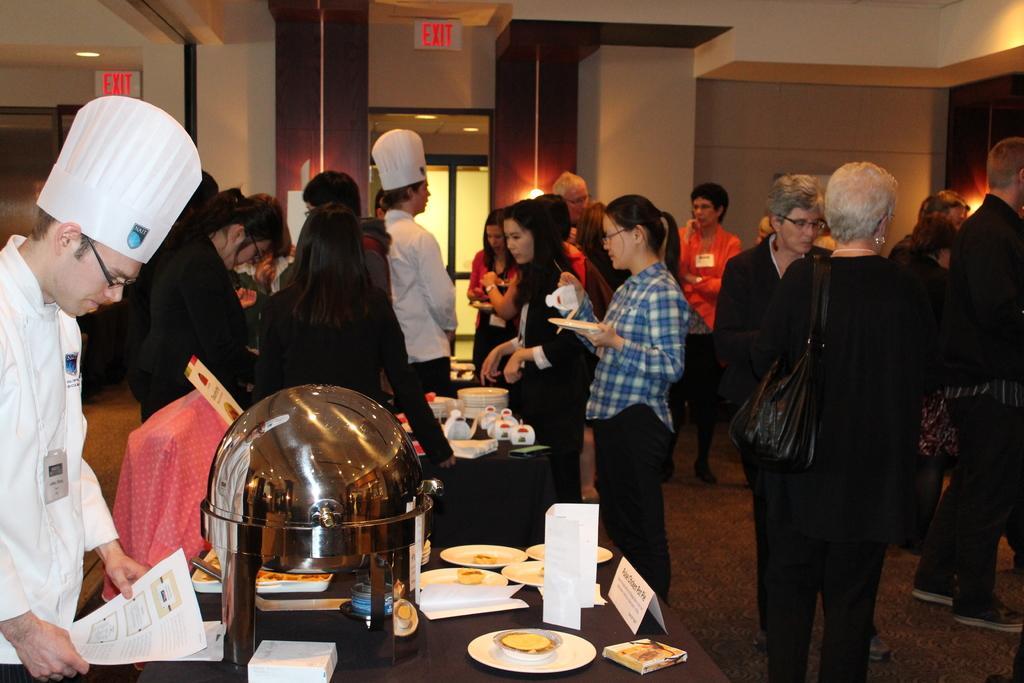Could you give a brief overview of what you see in this image? In the picture I can see a group of people standing on the floor. I can see a woman on the right side is carrying a black color bag. There is a woman wearing a blue color shirt and she is holding a plate in her hands. I can see the tables on the floor and the tables are covered with black color cloth. I can see the plates, dish name board and stainless steel dish bowl are kept on the table. There is a man on the left side is wearing a chief dress and he is holding the papers. I can see the glass door in the background. 